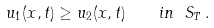Convert formula to latex. <formula><loc_0><loc_0><loc_500><loc_500>u _ { 1 } ( x , t ) \geq u _ { 2 } ( x , t ) \quad i n \ S _ { T } \, .</formula> 